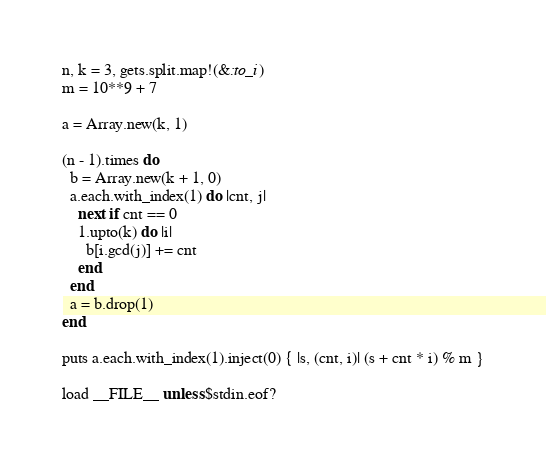<code> <loc_0><loc_0><loc_500><loc_500><_Ruby_>n, k = 3, gets.split.map!(&:to_i)
m = 10**9 + 7

a = Array.new(k, 1)

(n - 1).times do
  b = Array.new(k + 1, 0)
  a.each.with_index(1) do |cnt, j|
    next if cnt == 0
    1.upto(k) do |i|
      b[i.gcd(j)] += cnt
    end
  end
  a = b.drop(1)
end

puts a.each.with_index(1).inject(0) { |s, (cnt, i)| (s + cnt * i) % m }

load __FILE__ unless $stdin.eof?
</code> 